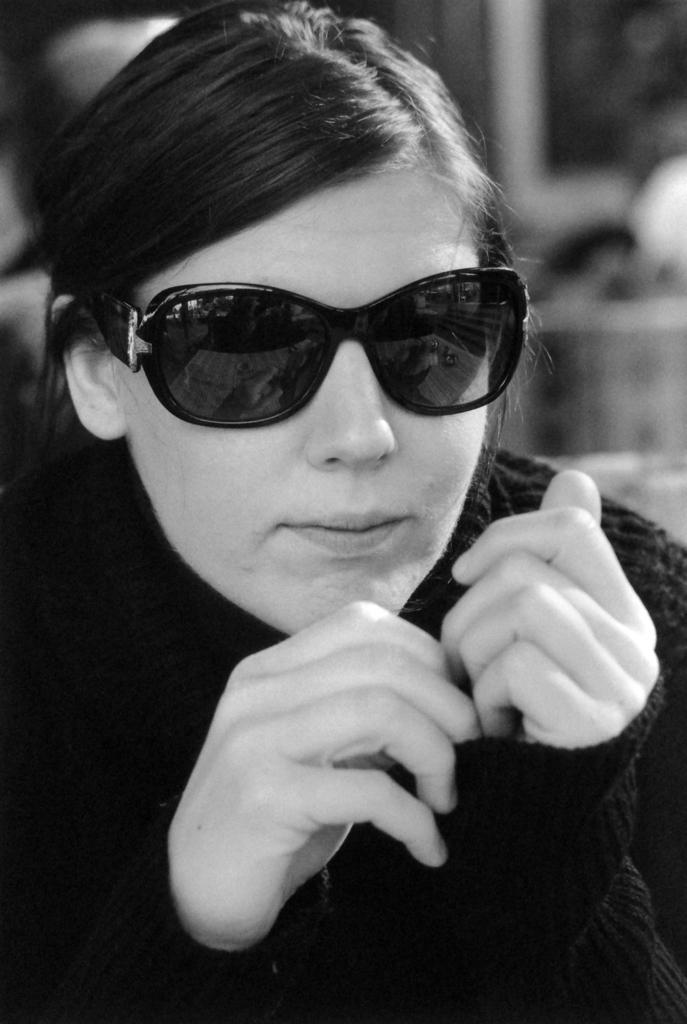What is the color scheme of the image? The image is black and white. Who is present in the image? There is a woman in the image. What is the woman wearing on her face? The woman is wearing goggles. What type of bird can be seen flying in the image? There are no birds present in the image; it is a black and white image of a woman wearing goggles. 